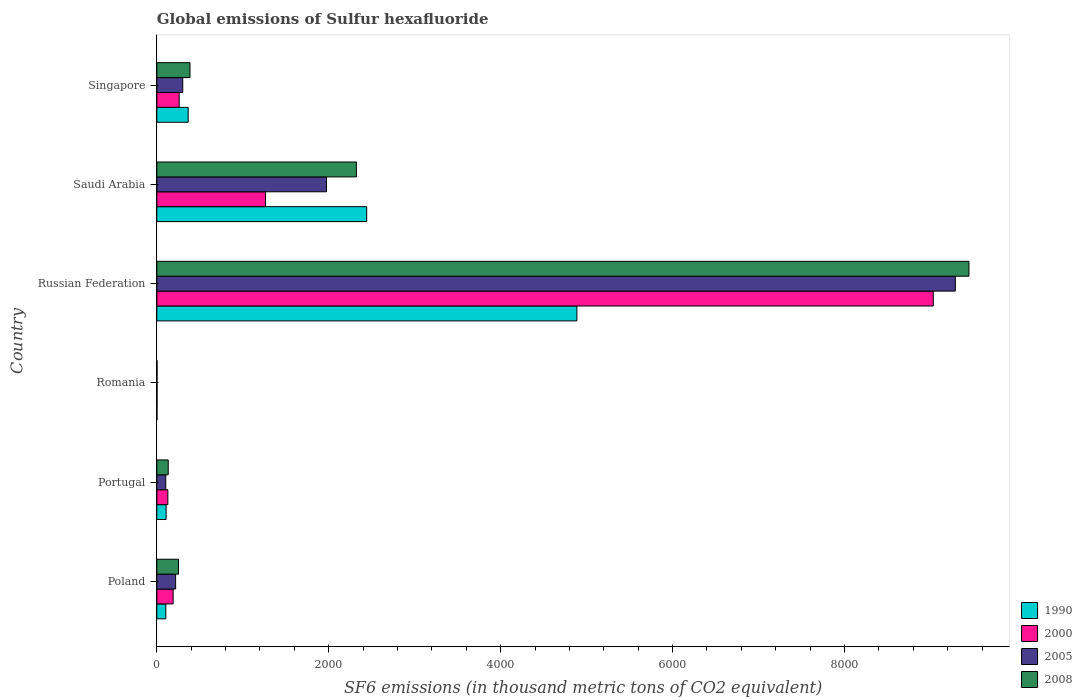How many different coloured bars are there?
Provide a succinct answer. 4. How many groups of bars are there?
Offer a terse response. 6. Are the number of bars per tick equal to the number of legend labels?
Your answer should be very brief. Yes. How many bars are there on the 6th tick from the bottom?
Provide a short and direct response. 4. What is the label of the 5th group of bars from the top?
Provide a short and direct response. Portugal. Across all countries, what is the maximum global emissions of Sulfur hexafluoride in 1990?
Your response must be concise. 4886.8. Across all countries, what is the minimum global emissions of Sulfur hexafluoride in 2005?
Make the answer very short. 2.2. In which country was the global emissions of Sulfur hexafluoride in 2008 maximum?
Make the answer very short. Russian Federation. In which country was the global emissions of Sulfur hexafluoride in 2005 minimum?
Provide a succinct answer. Romania. What is the total global emissions of Sulfur hexafluoride in 1990 in the graph?
Your answer should be very brief. 7906.7. What is the difference between the global emissions of Sulfur hexafluoride in 2000 in Poland and that in Russian Federation?
Keep it short and to the point. -8843.4. What is the difference between the global emissions of Sulfur hexafluoride in 1990 in Russian Federation and the global emissions of Sulfur hexafluoride in 2005 in Romania?
Provide a succinct answer. 4884.6. What is the average global emissions of Sulfur hexafluoride in 2005 per country?
Ensure brevity in your answer.  1981.57. What is the difference between the global emissions of Sulfur hexafluoride in 2008 and global emissions of Sulfur hexafluoride in 2000 in Poland?
Your response must be concise. 61.9. In how many countries, is the global emissions of Sulfur hexafluoride in 2005 greater than 1200 thousand metric tons?
Keep it short and to the point. 2. What is the ratio of the global emissions of Sulfur hexafluoride in 2008 in Saudi Arabia to that in Singapore?
Provide a short and direct response. 6.02. Is the global emissions of Sulfur hexafluoride in 2000 in Romania less than that in Saudi Arabia?
Ensure brevity in your answer.  Yes. Is the difference between the global emissions of Sulfur hexafluoride in 2008 in Russian Federation and Singapore greater than the difference between the global emissions of Sulfur hexafluoride in 2000 in Russian Federation and Singapore?
Ensure brevity in your answer.  Yes. What is the difference between the highest and the second highest global emissions of Sulfur hexafluoride in 2000?
Make the answer very short. 7768.6. What is the difference between the highest and the lowest global emissions of Sulfur hexafluoride in 2000?
Provide a succinct answer. 9031.2. Is the sum of the global emissions of Sulfur hexafluoride in 1990 in Russian Federation and Saudi Arabia greater than the maximum global emissions of Sulfur hexafluoride in 2008 across all countries?
Your answer should be very brief. No. Is it the case that in every country, the sum of the global emissions of Sulfur hexafluoride in 2008 and global emissions of Sulfur hexafluoride in 2005 is greater than the sum of global emissions of Sulfur hexafluoride in 1990 and global emissions of Sulfur hexafluoride in 2000?
Provide a succinct answer. No. Is it the case that in every country, the sum of the global emissions of Sulfur hexafluoride in 2005 and global emissions of Sulfur hexafluoride in 2000 is greater than the global emissions of Sulfur hexafluoride in 1990?
Your answer should be very brief. Yes. How many bars are there?
Ensure brevity in your answer.  24. How many countries are there in the graph?
Offer a very short reply. 6. Are the values on the major ticks of X-axis written in scientific E-notation?
Provide a short and direct response. No. Where does the legend appear in the graph?
Provide a succinct answer. Bottom right. How many legend labels are there?
Ensure brevity in your answer.  4. How are the legend labels stacked?
Provide a short and direct response. Vertical. What is the title of the graph?
Give a very brief answer. Global emissions of Sulfur hexafluoride. What is the label or title of the X-axis?
Keep it short and to the point. SF6 emissions (in thousand metric tons of CO2 equivalent). What is the SF6 emissions (in thousand metric tons of CO2 equivalent) of 1990 in Poland?
Make the answer very short. 104.3. What is the SF6 emissions (in thousand metric tons of CO2 equivalent) of 2000 in Poland?
Ensure brevity in your answer.  189.8. What is the SF6 emissions (in thousand metric tons of CO2 equivalent) of 2005 in Poland?
Give a very brief answer. 218.5. What is the SF6 emissions (in thousand metric tons of CO2 equivalent) in 2008 in Poland?
Offer a terse response. 251.7. What is the SF6 emissions (in thousand metric tons of CO2 equivalent) of 1990 in Portugal?
Ensure brevity in your answer.  108. What is the SF6 emissions (in thousand metric tons of CO2 equivalent) of 2000 in Portugal?
Ensure brevity in your answer.  128. What is the SF6 emissions (in thousand metric tons of CO2 equivalent) of 2005 in Portugal?
Offer a very short reply. 103.8. What is the SF6 emissions (in thousand metric tons of CO2 equivalent) in 2008 in Portugal?
Your answer should be very brief. 132.4. What is the SF6 emissions (in thousand metric tons of CO2 equivalent) of 2000 in Romania?
Your answer should be compact. 2. What is the SF6 emissions (in thousand metric tons of CO2 equivalent) in 1990 in Russian Federation?
Keep it short and to the point. 4886.8. What is the SF6 emissions (in thousand metric tons of CO2 equivalent) in 2000 in Russian Federation?
Provide a short and direct response. 9033.2. What is the SF6 emissions (in thousand metric tons of CO2 equivalent) of 2005 in Russian Federation?
Offer a very short reply. 9289.9. What is the SF6 emissions (in thousand metric tons of CO2 equivalent) in 2008 in Russian Federation?
Your response must be concise. 9448.2. What is the SF6 emissions (in thousand metric tons of CO2 equivalent) of 1990 in Saudi Arabia?
Give a very brief answer. 2441.3. What is the SF6 emissions (in thousand metric tons of CO2 equivalent) of 2000 in Saudi Arabia?
Ensure brevity in your answer.  1264.6. What is the SF6 emissions (in thousand metric tons of CO2 equivalent) in 2005 in Saudi Arabia?
Provide a short and direct response. 1973.8. What is the SF6 emissions (in thousand metric tons of CO2 equivalent) in 2008 in Saudi Arabia?
Give a very brief answer. 2321.8. What is the SF6 emissions (in thousand metric tons of CO2 equivalent) of 1990 in Singapore?
Offer a terse response. 364.7. What is the SF6 emissions (in thousand metric tons of CO2 equivalent) in 2000 in Singapore?
Your answer should be compact. 259.8. What is the SF6 emissions (in thousand metric tons of CO2 equivalent) of 2005 in Singapore?
Offer a very short reply. 301.2. What is the SF6 emissions (in thousand metric tons of CO2 equivalent) in 2008 in Singapore?
Offer a very short reply. 385.5. Across all countries, what is the maximum SF6 emissions (in thousand metric tons of CO2 equivalent) in 1990?
Provide a short and direct response. 4886.8. Across all countries, what is the maximum SF6 emissions (in thousand metric tons of CO2 equivalent) in 2000?
Provide a succinct answer. 9033.2. Across all countries, what is the maximum SF6 emissions (in thousand metric tons of CO2 equivalent) of 2005?
Your answer should be compact. 9289.9. Across all countries, what is the maximum SF6 emissions (in thousand metric tons of CO2 equivalent) in 2008?
Provide a succinct answer. 9448.2. Across all countries, what is the minimum SF6 emissions (in thousand metric tons of CO2 equivalent) in 1990?
Your answer should be very brief. 1.6. Across all countries, what is the minimum SF6 emissions (in thousand metric tons of CO2 equivalent) in 2000?
Offer a terse response. 2. Across all countries, what is the minimum SF6 emissions (in thousand metric tons of CO2 equivalent) in 2005?
Your response must be concise. 2.2. What is the total SF6 emissions (in thousand metric tons of CO2 equivalent) of 1990 in the graph?
Provide a short and direct response. 7906.7. What is the total SF6 emissions (in thousand metric tons of CO2 equivalent) of 2000 in the graph?
Give a very brief answer. 1.09e+04. What is the total SF6 emissions (in thousand metric tons of CO2 equivalent) of 2005 in the graph?
Keep it short and to the point. 1.19e+04. What is the total SF6 emissions (in thousand metric tons of CO2 equivalent) of 2008 in the graph?
Your answer should be compact. 1.25e+04. What is the difference between the SF6 emissions (in thousand metric tons of CO2 equivalent) in 1990 in Poland and that in Portugal?
Provide a short and direct response. -3.7. What is the difference between the SF6 emissions (in thousand metric tons of CO2 equivalent) of 2000 in Poland and that in Portugal?
Keep it short and to the point. 61.8. What is the difference between the SF6 emissions (in thousand metric tons of CO2 equivalent) of 2005 in Poland and that in Portugal?
Give a very brief answer. 114.7. What is the difference between the SF6 emissions (in thousand metric tons of CO2 equivalent) in 2008 in Poland and that in Portugal?
Offer a terse response. 119.3. What is the difference between the SF6 emissions (in thousand metric tons of CO2 equivalent) in 1990 in Poland and that in Romania?
Give a very brief answer. 102.7. What is the difference between the SF6 emissions (in thousand metric tons of CO2 equivalent) in 2000 in Poland and that in Romania?
Offer a very short reply. 187.8. What is the difference between the SF6 emissions (in thousand metric tons of CO2 equivalent) of 2005 in Poland and that in Romania?
Keep it short and to the point. 216.3. What is the difference between the SF6 emissions (in thousand metric tons of CO2 equivalent) of 2008 in Poland and that in Romania?
Provide a succinct answer. 249.4. What is the difference between the SF6 emissions (in thousand metric tons of CO2 equivalent) of 1990 in Poland and that in Russian Federation?
Provide a short and direct response. -4782.5. What is the difference between the SF6 emissions (in thousand metric tons of CO2 equivalent) of 2000 in Poland and that in Russian Federation?
Offer a terse response. -8843.4. What is the difference between the SF6 emissions (in thousand metric tons of CO2 equivalent) of 2005 in Poland and that in Russian Federation?
Your response must be concise. -9071.4. What is the difference between the SF6 emissions (in thousand metric tons of CO2 equivalent) in 2008 in Poland and that in Russian Federation?
Your response must be concise. -9196.5. What is the difference between the SF6 emissions (in thousand metric tons of CO2 equivalent) of 1990 in Poland and that in Saudi Arabia?
Offer a very short reply. -2337. What is the difference between the SF6 emissions (in thousand metric tons of CO2 equivalent) in 2000 in Poland and that in Saudi Arabia?
Make the answer very short. -1074.8. What is the difference between the SF6 emissions (in thousand metric tons of CO2 equivalent) in 2005 in Poland and that in Saudi Arabia?
Your answer should be compact. -1755.3. What is the difference between the SF6 emissions (in thousand metric tons of CO2 equivalent) in 2008 in Poland and that in Saudi Arabia?
Your response must be concise. -2070.1. What is the difference between the SF6 emissions (in thousand metric tons of CO2 equivalent) in 1990 in Poland and that in Singapore?
Offer a terse response. -260.4. What is the difference between the SF6 emissions (in thousand metric tons of CO2 equivalent) in 2000 in Poland and that in Singapore?
Keep it short and to the point. -70. What is the difference between the SF6 emissions (in thousand metric tons of CO2 equivalent) of 2005 in Poland and that in Singapore?
Your answer should be compact. -82.7. What is the difference between the SF6 emissions (in thousand metric tons of CO2 equivalent) in 2008 in Poland and that in Singapore?
Ensure brevity in your answer.  -133.8. What is the difference between the SF6 emissions (in thousand metric tons of CO2 equivalent) in 1990 in Portugal and that in Romania?
Keep it short and to the point. 106.4. What is the difference between the SF6 emissions (in thousand metric tons of CO2 equivalent) in 2000 in Portugal and that in Romania?
Make the answer very short. 126. What is the difference between the SF6 emissions (in thousand metric tons of CO2 equivalent) in 2005 in Portugal and that in Romania?
Provide a short and direct response. 101.6. What is the difference between the SF6 emissions (in thousand metric tons of CO2 equivalent) of 2008 in Portugal and that in Romania?
Your answer should be very brief. 130.1. What is the difference between the SF6 emissions (in thousand metric tons of CO2 equivalent) in 1990 in Portugal and that in Russian Federation?
Keep it short and to the point. -4778.8. What is the difference between the SF6 emissions (in thousand metric tons of CO2 equivalent) of 2000 in Portugal and that in Russian Federation?
Offer a very short reply. -8905.2. What is the difference between the SF6 emissions (in thousand metric tons of CO2 equivalent) in 2005 in Portugal and that in Russian Federation?
Make the answer very short. -9186.1. What is the difference between the SF6 emissions (in thousand metric tons of CO2 equivalent) in 2008 in Portugal and that in Russian Federation?
Provide a short and direct response. -9315.8. What is the difference between the SF6 emissions (in thousand metric tons of CO2 equivalent) of 1990 in Portugal and that in Saudi Arabia?
Your answer should be very brief. -2333.3. What is the difference between the SF6 emissions (in thousand metric tons of CO2 equivalent) in 2000 in Portugal and that in Saudi Arabia?
Provide a succinct answer. -1136.6. What is the difference between the SF6 emissions (in thousand metric tons of CO2 equivalent) in 2005 in Portugal and that in Saudi Arabia?
Give a very brief answer. -1870. What is the difference between the SF6 emissions (in thousand metric tons of CO2 equivalent) in 2008 in Portugal and that in Saudi Arabia?
Your response must be concise. -2189.4. What is the difference between the SF6 emissions (in thousand metric tons of CO2 equivalent) of 1990 in Portugal and that in Singapore?
Offer a terse response. -256.7. What is the difference between the SF6 emissions (in thousand metric tons of CO2 equivalent) of 2000 in Portugal and that in Singapore?
Your answer should be very brief. -131.8. What is the difference between the SF6 emissions (in thousand metric tons of CO2 equivalent) of 2005 in Portugal and that in Singapore?
Ensure brevity in your answer.  -197.4. What is the difference between the SF6 emissions (in thousand metric tons of CO2 equivalent) of 2008 in Portugal and that in Singapore?
Your answer should be very brief. -253.1. What is the difference between the SF6 emissions (in thousand metric tons of CO2 equivalent) of 1990 in Romania and that in Russian Federation?
Offer a terse response. -4885.2. What is the difference between the SF6 emissions (in thousand metric tons of CO2 equivalent) of 2000 in Romania and that in Russian Federation?
Your answer should be compact. -9031.2. What is the difference between the SF6 emissions (in thousand metric tons of CO2 equivalent) of 2005 in Romania and that in Russian Federation?
Make the answer very short. -9287.7. What is the difference between the SF6 emissions (in thousand metric tons of CO2 equivalent) in 2008 in Romania and that in Russian Federation?
Make the answer very short. -9445.9. What is the difference between the SF6 emissions (in thousand metric tons of CO2 equivalent) of 1990 in Romania and that in Saudi Arabia?
Keep it short and to the point. -2439.7. What is the difference between the SF6 emissions (in thousand metric tons of CO2 equivalent) of 2000 in Romania and that in Saudi Arabia?
Offer a very short reply. -1262.6. What is the difference between the SF6 emissions (in thousand metric tons of CO2 equivalent) in 2005 in Romania and that in Saudi Arabia?
Offer a very short reply. -1971.6. What is the difference between the SF6 emissions (in thousand metric tons of CO2 equivalent) in 2008 in Romania and that in Saudi Arabia?
Keep it short and to the point. -2319.5. What is the difference between the SF6 emissions (in thousand metric tons of CO2 equivalent) in 1990 in Romania and that in Singapore?
Your response must be concise. -363.1. What is the difference between the SF6 emissions (in thousand metric tons of CO2 equivalent) of 2000 in Romania and that in Singapore?
Your answer should be compact. -257.8. What is the difference between the SF6 emissions (in thousand metric tons of CO2 equivalent) in 2005 in Romania and that in Singapore?
Make the answer very short. -299. What is the difference between the SF6 emissions (in thousand metric tons of CO2 equivalent) in 2008 in Romania and that in Singapore?
Your answer should be compact. -383.2. What is the difference between the SF6 emissions (in thousand metric tons of CO2 equivalent) of 1990 in Russian Federation and that in Saudi Arabia?
Provide a succinct answer. 2445.5. What is the difference between the SF6 emissions (in thousand metric tons of CO2 equivalent) of 2000 in Russian Federation and that in Saudi Arabia?
Your answer should be very brief. 7768.6. What is the difference between the SF6 emissions (in thousand metric tons of CO2 equivalent) of 2005 in Russian Federation and that in Saudi Arabia?
Offer a very short reply. 7316.1. What is the difference between the SF6 emissions (in thousand metric tons of CO2 equivalent) in 2008 in Russian Federation and that in Saudi Arabia?
Provide a succinct answer. 7126.4. What is the difference between the SF6 emissions (in thousand metric tons of CO2 equivalent) of 1990 in Russian Federation and that in Singapore?
Keep it short and to the point. 4522.1. What is the difference between the SF6 emissions (in thousand metric tons of CO2 equivalent) in 2000 in Russian Federation and that in Singapore?
Offer a terse response. 8773.4. What is the difference between the SF6 emissions (in thousand metric tons of CO2 equivalent) in 2005 in Russian Federation and that in Singapore?
Ensure brevity in your answer.  8988.7. What is the difference between the SF6 emissions (in thousand metric tons of CO2 equivalent) of 2008 in Russian Federation and that in Singapore?
Give a very brief answer. 9062.7. What is the difference between the SF6 emissions (in thousand metric tons of CO2 equivalent) of 1990 in Saudi Arabia and that in Singapore?
Offer a terse response. 2076.6. What is the difference between the SF6 emissions (in thousand metric tons of CO2 equivalent) of 2000 in Saudi Arabia and that in Singapore?
Provide a short and direct response. 1004.8. What is the difference between the SF6 emissions (in thousand metric tons of CO2 equivalent) in 2005 in Saudi Arabia and that in Singapore?
Provide a succinct answer. 1672.6. What is the difference between the SF6 emissions (in thousand metric tons of CO2 equivalent) of 2008 in Saudi Arabia and that in Singapore?
Your response must be concise. 1936.3. What is the difference between the SF6 emissions (in thousand metric tons of CO2 equivalent) of 1990 in Poland and the SF6 emissions (in thousand metric tons of CO2 equivalent) of 2000 in Portugal?
Your answer should be very brief. -23.7. What is the difference between the SF6 emissions (in thousand metric tons of CO2 equivalent) in 1990 in Poland and the SF6 emissions (in thousand metric tons of CO2 equivalent) in 2008 in Portugal?
Give a very brief answer. -28.1. What is the difference between the SF6 emissions (in thousand metric tons of CO2 equivalent) of 2000 in Poland and the SF6 emissions (in thousand metric tons of CO2 equivalent) of 2008 in Portugal?
Ensure brevity in your answer.  57.4. What is the difference between the SF6 emissions (in thousand metric tons of CO2 equivalent) of 2005 in Poland and the SF6 emissions (in thousand metric tons of CO2 equivalent) of 2008 in Portugal?
Make the answer very short. 86.1. What is the difference between the SF6 emissions (in thousand metric tons of CO2 equivalent) of 1990 in Poland and the SF6 emissions (in thousand metric tons of CO2 equivalent) of 2000 in Romania?
Keep it short and to the point. 102.3. What is the difference between the SF6 emissions (in thousand metric tons of CO2 equivalent) in 1990 in Poland and the SF6 emissions (in thousand metric tons of CO2 equivalent) in 2005 in Romania?
Offer a terse response. 102.1. What is the difference between the SF6 emissions (in thousand metric tons of CO2 equivalent) of 1990 in Poland and the SF6 emissions (in thousand metric tons of CO2 equivalent) of 2008 in Romania?
Your response must be concise. 102. What is the difference between the SF6 emissions (in thousand metric tons of CO2 equivalent) of 2000 in Poland and the SF6 emissions (in thousand metric tons of CO2 equivalent) of 2005 in Romania?
Provide a succinct answer. 187.6. What is the difference between the SF6 emissions (in thousand metric tons of CO2 equivalent) of 2000 in Poland and the SF6 emissions (in thousand metric tons of CO2 equivalent) of 2008 in Romania?
Give a very brief answer. 187.5. What is the difference between the SF6 emissions (in thousand metric tons of CO2 equivalent) in 2005 in Poland and the SF6 emissions (in thousand metric tons of CO2 equivalent) in 2008 in Romania?
Give a very brief answer. 216.2. What is the difference between the SF6 emissions (in thousand metric tons of CO2 equivalent) in 1990 in Poland and the SF6 emissions (in thousand metric tons of CO2 equivalent) in 2000 in Russian Federation?
Provide a short and direct response. -8928.9. What is the difference between the SF6 emissions (in thousand metric tons of CO2 equivalent) in 1990 in Poland and the SF6 emissions (in thousand metric tons of CO2 equivalent) in 2005 in Russian Federation?
Offer a terse response. -9185.6. What is the difference between the SF6 emissions (in thousand metric tons of CO2 equivalent) in 1990 in Poland and the SF6 emissions (in thousand metric tons of CO2 equivalent) in 2008 in Russian Federation?
Your answer should be compact. -9343.9. What is the difference between the SF6 emissions (in thousand metric tons of CO2 equivalent) in 2000 in Poland and the SF6 emissions (in thousand metric tons of CO2 equivalent) in 2005 in Russian Federation?
Make the answer very short. -9100.1. What is the difference between the SF6 emissions (in thousand metric tons of CO2 equivalent) in 2000 in Poland and the SF6 emissions (in thousand metric tons of CO2 equivalent) in 2008 in Russian Federation?
Offer a terse response. -9258.4. What is the difference between the SF6 emissions (in thousand metric tons of CO2 equivalent) of 2005 in Poland and the SF6 emissions (in thousand metric tons of CO2 equivalent) of 2008 in Russian Federation?
Provide a short and direct response. -9229.7. What is the difference between the SF6 emissions (in thousand metric tons of CO2 equivalent) in 1990 in Poland and the SF6 emissions (in thousand metric tons of CO2 equivalent) in 2000 in Saudi Arabia?
Your answer should be very brief. -1160.3. What is the difference between the SF6 emissions (in thousand metric tons of CO2 equivalent) of 1990 in Poland and the SF6 emissions (in thousand metric tons of CO2 equivalent) of 2005 in Saudi Arabia?
Your response must be concise. -1869.5. What is the difference between the SF6 emissions (in thousand metric tons of CO2 equivalent) in 1990 in Poland and the SF6 emissions (in thousand metric tons of CO2 equivalent) in 2008 in Saudi Arabia?
Keep it short and to the point. -2217.5. What is the difference between the SF6 emissions (in thousand metric tons of CO2 equivalent) in 2000 in Poland and the SF6 emissions (in thousand metric tons of CO2 equivalent) in 2005 in Saudi Arabia?
Give a very brief answer. -1784. What is the difference between the SF6 emissions (in thousand metric tons of CO2 equivalent) in 2000 in Poland and the SF6 emissions (in thousand metric tons of CO2 equivalent) in 2008 in Saudi Arabia?
Provide a short and direct response. -2132. What is the difference between the SF6 emissions (in thousand metric tons of CO2 equivalent) of 2005 in Poland and the SF6 emissions (in thousand metric tons of CO2 equivalent) of 2008 in Saudi Arabia?
Keep it short and to the point. -2103.3. What is the difference between the SF6 emissions (in thousand metric tons of CO2 equivalent) of 1990 in Poland and the SF6 emissions (in thousand metric tons of CO2 equivalent) of 2000 in Singapore?
Provide a short and direct response. -155.5. What is the difference between the SF6 emissions (in thousand metric tons of CO2 equivalent) of 1990 in Poland and the SF6 emissions (in thousand metric tons of CO2 equivalent) of 2005 in Singapore?
Ensure brevity in your answer.  -196.9. What is the difference between the SF6 emissions (in thousand metric tons of CO2 equivalent) in 1990 in Poland and the SF6 emissions (in thousand metric tons of CO2 equivalent) in 2008 in Singapore?
Your answer should be very brief. -281.2. What is the difference between the SF6 emissions (in thousand metric tons of CO2 equivalent) of 2000 in Poland and the SF6 emissions (in thousand metric tons of CO2 equivalent) of 2005 in Singapore?
Offer a terse response. -111.4. What is the difference between the SF6 emissions (in thousand metric tons of CO2 equivalent) of 2000 in Poland and the SF6 emissions (in thousand metric tons of CO2 equivalent) of 2008 in Singapore?
Your answer should be compact. -195.7. What is the difference between the SF6 emissions (in thousand metric tons of CO2 equivalent) in 2005 in Poland and the SF6 emissions (in thousand metric tons of CO2 equivalent) in 2008 in Singapore?
Your answer should be very brief. -167. What is the difference between the SF6 emissions (in thousand metric tons of CO2 equivalent) in 1990 in Portugal and the SF6 emissions (in thousand metric tons of CO2 equivalent) in 2000 in Romania?
Provide a short and direct response. 106. What is the difference between the SF6 emissions (in thousand metric tons of CO2 equivalent) in 1990 in Portugal and the SF6 emissions (in thousand metric tons of CO2 equivalent) in 2005 in Romania?
Make the answer very short. 105.8. What is the difference between the SF6 emissions (in thousand metric tons of CO2 equivalent) of 1990 in Portugal and the SF6 emissions (in thousand metric tons of CO2 equivalent) of 2008 in Romania?
Your answer should be very brief. 105.7. What is the difference between the SF6 emissions (in thousand metric tons of CO2 equivalent) of 2000 in Portugal and the SF6 emissions (in thousand metric tons of CO2 equivalent) of 2005 in Romania?
Ensure brevity in your answer.  125.8. What is the difference between the SF6 emissions (in thousand metric tons of CO2 equivalent) in 2000 in Portugal and the SF6 emissions (in thousand metric tons of CO2 equivalent) in 2008 in Romania?
Your response must be concise. 125.7. What is the difference between the SF6 emissions (in thousand metric tons of CO2 equivalent) in 2005 in Portugal and the SF6 emissions (in thousand metric tons of CO2 equivalent) in 2008 in Romania?
Keep it short and to the point. 101.5. What is the difference between the SF6 emissions (in thousand metric tons of CO2 equivalent) in 1990 in Portugal and the SF6 emissions (in thousand metric tons of CO2 equivalent) in 2000 in Russian Federation?
Your answer should be compact. -8925.2. What is the difference between the SF6 emissions (in thousand metric tons of CO2 equivalent) in 1990 in Portugal and the SF6 emissions (in thousand metric tons of CO2 equivalent) in 2005 in Russian Federation?
Offer a very short reply. -9181.9. What is the difference between the SF6 emissions (in thousand metric tons of CO2 equivalent) of 1990 in Portugal and the SF6 emissions (in thousand metric tons of CO2 equivalent) of 2008 in Russian Federation?
Provide a succinct answer. -9340.2. What is the difference between the SF6 emissions (in thousand metric tons of CO2 equivalent) of 2000 in Portugal and the SF6 emissions (in thousand metric tons of CO2 equivalent) of 2005 in Russian Federation?
Provide a succinct answer. -9161.9. What is the difference between the SF6 emissions (in thousand metric tons of CO2 equivalent) in 2000 in Portugal and the SF6 emissions (in thousand metric tons of CO2 equivalent) in 2008 in Russian Federation?
Provide a succinct answer. -9320.2. What is the difference between the SF6 emissions (in thousand metric tons of CO2 equivalent) in 2005 in Portugal and the SF6 emissions (in thousand metric tons of CO2 equivalent) in 2008 in Russian Federation?
Ensure brevity in your answer.  -9344.4. What is the difference between the SF6 emissions (in thousand metric tons of CO2 equivalent) of 1990 in Portugal and the SF6 emissions (in thousand metric tons of CO2 equivalent) of 2000 in Saudi Arabia?
Give a very brief answer. -1156.6. What is the difference between the SF6 emissions (in thousand metric tons of CO2 equivalent) in 1990 in Portugal and the SF6 emissions (in thousand metric tons of CO2 equivalent) in 2005 in Saudi Arabia?
Your answer should be compact. -1865.8. What is the difference between the SF6 emissions (in thousand metric tons of CO2 equivalent) in 1990 in Portugal and the SF6 emissions (in thousand metric tons of CO2 equivalent) in 2008 in Saudi Arabia?
Provide a short and direct response. -2213.8. What is the difference between the SF6 emissions (in thousand metric tons of CO2 equivalent) of 2000 in Portugal and the SF6 emissions (in thousand metric tons of CO2 equivalent) of 2005 in Saudi Arabia?
Your answer should be compact. -1845.8. What is the difference between the SF6 emissions (in thousand metric tons of CO2 equivalent) in 2000 in Portugal and the SF6 emissions (in thousand metric tons of CO2 equivalent) in 2008 in Saudi Arabia?
Provide a short and direct response. -2193.8. What is the difference between the SF6 emissions (in thousand metric tons of CO2 equivalent) in 2005 in Portugal and the SF6 emissions (in thousand metric tons of CO2 equivalent) in 2008 in Saudi Arabia?
Provide a succinct answer. -2218. What is the difference between the SF6 emissions (in thousand metric tons of CO2 equivalent) in 1990 in Portugal and the SF6 emissions (in thousand metric tons of CO2 equivalent) in 2000 in Singapore?
Provide a succinct answer. -151.8. What is the difference between the SF6 emissions (in thousand metric tons of CO2 equivalent) in 1990 in Portugal and the SF6 emissions (in thousand metric tons of CO2 equivalent) in 2005 in Singapore?
Make the answer very short. -193.2. What is the difference between the SF6 emissions (in thousand metric tons of CO2 equivalent) in 1990 in Portugal and the SF6 emissions (in thousand metric tons of CO2 equivalent) in 2008 in Singapore?
Ensure brevity in your answer.  -277.5. What is the difference between the SF6 emissions (in thousand metric tons of CO2 equivalent) in 2000 in Portugal and the SF6 emissions (in thousand metric tons of CO2 equivalent) in 2005 in Singapore?
Keep it short and to the point. -173.2. What is the difference between the SF6 emissions (in thousand metric tons of CO2 equivalent) of 2000 in Portugal and the SF6 emissions (in thousand metric tons of CO2 equivalent) of 2008 in Singapore?
Make the answer very short. -257.5. What is the difference between the SF6 emissions (in thousand metric tons of CO2 equivalent) of 2005 in Portugal and the SF6 emissions (in thousand metric tons of CO2 equivalent) of 2008 in Singapore?
Make the answer very short. -281.7. What is the difference between the SF6 emissions (in thousand metric tons of CO2 equivalent) of 1990 in Romania and the SF6 emissions (in thousand metric tons of CO2 equivalent) of 2000 in Russian Federation?
Offer a terse response. -9031.6. What is the difference between the SF6 emissions (in thousand metric tons of CO2 equivalent) in 1990 in Romania and the SF6 emissions (in thousand metric tons of CO2 equivalent) in 2005 in Russian Federation?
Your answer should be compact. -9288.3. What is the difference between the SF6 emissions (in thousand metric tons of CO2 equivalent) of 1990 in Romania and the SF6 emissions (in thousand metric tons of CO2 equivalent) of 2008 in Russian Federation?
Make the answer very short. -9446.6. What is the difference between the SF6 emissions (in thousand metric tons of CO2 equivalent) in 2000 in Romania and the SF6 emissions (in thousand metric tons of CO2 equivalent) in 2005 in Russian Federation?
Your answer should be compact. -9287.9. What is the difference between the SF6 emissions (in thousand metric tons of CO2 equivalent) of 2000 in Romania and the SF6 emissions (in thousand metric tons of CO2 equivalent) of 2008 in Russian Federation?
Offer a very short reply. -9446.2. What is the difference between the SF6 emissions (in thousand metric tons of CO2 equivalent) in 2005 in Romania and the SF6 emissions (in thousand metric tons of CO2 equivalent) in 2008 in Russian Federation?
Your answer should be very brief. -9446. What is the difference between the SF6 emissions (in thousand metric tons of CO2 equivalent) in 1990 in Romania and the SF6 emissions (in thousand metric tons of CO2 equivalent) in 2000 in Saudi Arabia?
Your answer should be compact. -1263. What is the difference between the SF6 emissions (in thousand metric tons of CO2 equivalent) of 1990 in Romania and the SF6 emissions (in thousand metric tons of CO2 equivalent) of 2005 in Saudi Arabia?
Provide a short and direct response. -1972.2. What is the difference between the SF6 emissions (in thousand metric tons of CO2 equivalent) of 1990 in Romania and the SF6 emissions (in thousand metric tons of CO2 equivalent) of 2008 in Saudi Arabia?
Offer a terse response. -2320.2. What is the difference between the SF6 emissions (in thousand metric tons of CO2 equivalent) of 2000 in Romania and the SF6 emissions (in thousand metric tons of CO2 equivalent) of 2005 in Saudi Arabia?
Give a very brief answer. -1971.8. What is the difference between the SF6 emissions (in thousand metric tons of CO2 equivalent) in 2000 in Romania and the SF6 emissions (in thousand metric tons of CO2 equivalent) in 2008 in Saudi Arabia?
Your answer should be compact. -2319.8. What is the difference between the SF6 emissions (in thousand metric tons of CO2 equivalent) in 2005 in Romania and the SF6 emissions (in thousand metric tons of CO2 equivalent) in 2008 in Saudi Arabia?
Keep it short and to the point. -2319.6. What is the difference between the SF6 emissions (in thousand metric tons of CO2 equivalent) in 1990 in Romania and the SF6 emissions (in thousand metric tons of CO2 equivalent) in 2000 in Singapore?
Provide a succinct answer. -258.2. What is the difference between the SF6 emissions (in thousand metric tons of CO2 equivalent) of 1990 in Romania and the SF6 emissions (in thousand metric tons of CO2 equivalent) of 2005 in Singapore?
Offer a terse response. -299.6. What is the difference between the SF6 emissions (in thousand metric tons of CO2 equivalent) of 1990 in Romania and the SF6 emissions (in thousand metric tons of CO2 equivalent) of 2008 in Singapore?
Offer a very short reply. -383.9. What is the difference between the SF6 emissions (in thousand metric tons of CO2 equivalent) in 2000 in Romania and the SF6 emissions (in thousand metric tons of CO2 equivalent) in 2005 in Singapore?
Ensure brevity in your answer.  -299.2. What is the difference between the SF6 emissions (in thousand metric tons of CO2 equivalent) in 2000 in Romania and the SF6 emissions (in thousand metric tons of CO2 equivalent) in 2008 in Singapore?
Make the answer very short. -383.5. What is the difference between the SF6 emissions (in thousand metric tons of CO2 equivalent) in 2005 in Romania and the SF6 emissions (in thousand metric tons of CO2 equivalent) in 2008 in Singapore?
Offer a very short reply. -383.3. What is the difference between the SF6 emissions (in thousand metric tons of CO2 equivalent) in 1990 in Russian Federation and the SF6 emissions (in thousand metric tons of CO2 equivalent) in 2000 in Saudi Arabia?
Offer a very short reply. 3622.2. What is the difference between the SF6 emissions (in thousand metric tons of CO2 equivalent) in 1990 in Russian Federation and the SF6 emissions (in thousand metric tons of CO2 equivalent) in 2005 in Saudi Arabia?
Provide a succinct answer. 2913. What is the difference between the SF6 emissions (in thousand metric tons of CO2 equivalent) in 1990 in Russian Federation and the SF6 emissions (in thousand metric tons of CO2 equivalent) in 2008 in Saudi Arabia?
Keep it short and to the point. 2565. What is the difference between the SF6 emissions (in thousand metric tons of CO2 equivalent) of 2000 in Russian Federation and the SF6 emissions (in thousand metric tons of CO2 equivalent) of 2005 in Saudi Arabia?
Offer a very short reply. 7059.4. What is the difference between the SF6 emissions (in thousand metric tons of CO2 equivalent) of 2000 in Russian Federation and the SF6 emissions (in thousand metric tons of CO2 equivalent) of 2008 in Saudi Arabia?
Provide a succinct answer. 6711.4. What is the difference between the SF6 emissions (in thousand metric tons of CO2 equivalent) in 2005 in Russian Federation and the SF6 emissions (in thousand metric tons of CO2 equivalent) in 2008 in Saudi Arabia?
Your response must be concise. 6968.1. What is the difference between the SF6 emissions (in thousand metric tons of CO2 equivalent) of 1990 in Russian Federation and the SF6 emissions (in thousand metric tons of CO2 equivalent) of 2000 in Singapore?
Give a very brief answer. 4627. What is the difference between the SF6 emissions (in thousand metric tons of CO2 equivalent) of 1990 in Russian Federation and the SF6 emissions (in thousand metric tons of CO2 equivalent) of 2005 in Singapore?
Provide a succinct answer. 4585.6. What is the difference between the SF6 emissions (in thousand metric tons of CO2 equivalent) of 1990 in Russian Federation and the SF6 emissions (in thousand metric tons of CO2 equivalent) of 2008 in Singapore?
Offer a terse response. 4501.3. What is the difference between the SF6 emissions (in thousand metric tons of CO2 equivalent) of 2000 in Russian Federation and the SF6 emissions (in thousand metric tons of CO2 equivalent) of 2005 in Singapore?
Your answer should be compact. 8732. What is the difference between the SF6 emissions (in thousand metric tons of CO2 equivalent) of 2000 in Russian Federation and the SF6 emissions (in thousand metric tons of CO2 equivalent) of 2008 in Singapore?
Provide a short and direct response. 8647.7. What is the difference between the SF6 emissions (in thousand metric tons of CO2 equivalent) in 2005 in Russian Federation and the SF6 emissions (in thousand metric tons of CO2 equivalent) in 2008 in Singapore?
Offer a very short reply. 8904.4. What is the difference between the SF6 emissions (in thousand metric tons of CO2 equivalent) in 1990 in Saudi Arabia and the SF6 emissions (in thousand metric tons of CO2 equivalent) in 2000 in Singapore?
Provide a succinct answer. 2181.5. What is the difference between the SF6 emissions (in thousand metric tons of CO2 equivalent) in 1990 in Saudi Arabia and the SF6 emissions (in thousand metric tons of CO2 equivalent) in 2005 in Singapore?
Offer a terse response. 2140.1. What is the difference between the SF6 emissions (in thousand metric tons of CO2 equivalent) of 1990 in Saudi Arabia and the SF6 emissions (in thousand metric tons of CO2 equivalent) of 2008 in Singapore?
Your answer should be very brief. 2055.8. What is the difference between the SF6 emissions (in thousand metric tons of CO2 equivalent) of 2000 in Saudi Arabia and the SF6 emissions (in thousand metric tons of CO2 equivalent) of 2005 in Singapore?
Give a very brief answer. 963.4. What is the difference between the SF6 emissions (in thousand metric tons of CO2 equivalent) in 2000 in Saudi Arabia and the SF6 emissions (in thousand metric tons of CO2 equivalent) in 2008 in Singapore?
Your response must be concise. 879.1. What is the difference between the SF6 emissions (in thousand metric tons of CO2 equivalent) of 2005 in Saudi Arabia and the SF6 emissions (in thousand metric tons of CO2 equivalent) of 2008 in Singapore?
Ensure brevity in your answer.  1588.3. What is the average SF6 emissions (in thousand metric tons of CO2 equivalent) of 1990 per country?
Your answer should be very brief. 1317.78. What is the average SF6 emissions (in thousand metric tons of CO2 equivalent) in 2000 per country?
Provide a succinct answer. 1812.9. What is the average SF6 emissions (in thousand metric tons of CO2 equivalent) of 2005 per country?
Your answer should be very brief. 1981.57. What is the average SF6 emissions (in thousand metric tons of CO2 equivalent) of 2008 per country?
Provide a short and direct response. 2090.32. What is the difference between the SF6 emissions (in thousand metric tons of CO2 equivalent) of 1990 and SF6 emissions (in thousand metric tons of CO2 equivalent) of 2000 in Poland?
Offer a terse response. -85.5. What is the difference between the SF6 emissions (in thousand metric tons of CO2 equivalent) of 1990 and SF6 emissions (in thousand metric tons of CO2 equivalent) of 2005 in Poland?
Keep it short and to the point. -114.2. What is the difference between the SF6 emissions (in thousand metric tons of CO2 equivalent) in 1990 and SF6 emissions (in thousand metric tons of CO2 equivalent) in 2008 in Poland?
Offer a very short reply. -147.4. What is the difference between the SF6 emissions (in thousand metric tons of CO2 equivalent) in 2000 and SF6 emissions (in thousand metric tons of CO2 equivalent) in 2005 in Poland?
Your answer should be very brief. -28.7. What is the difference between the SF6 emissions (in thousand metric tons of CO2 equivalent) in 2000 and SF6 emissions (in thousand metric tons of CO2 equivalent) in 2008 in Poland?
Your answer should be very brief. -61.9. What is the difference between the SF6 emissions (in thousand metric tons of CO2 equivalent) in 2005 and SF6 emissions (in thousand metric tons of CO2 equivalent) in 2008 in Poland?
Provide a succinct answer. -33.2. What is the difference between the SF6 emissions (in thousand metric tons of CO2 equivalent) of 1990 and SF6 emissions (in thousand metric tons of CO2 equivalent) of 2008 in Portugal?
Provide a succinct answer. -24.4. What is the difference between the SF6 emissions (in thousand metric tons of CO2 equivalent) in 2000 and SF6 emissions (in thousand metric tons of CO2 equivalent) in 2005 in Portugal?
Keep it short and to the point. 24.2. What is the difference between the SF6 emissions (in thousand metric tons of CO2 equivalent) of 2005 and SF6 emissions (in thousand metric tons of CO2 equivalent) of 2008 in Portugal?
Ensure brevity in your answer.  -28.6. What is the difference between the SF6 emissions (in thousand metric tons of CO2 equivalent) in 1990 and SF6 emissions (in thousand metric tons of CO2 equivalent) in 2000 in Romania?
Offer a very short reply. -0.4. What is the difference between the SF6 emissions (in thousand metric tons of CO2 equivalent) of 1990 and SF6 emissions (in thousand metric tons of CO2 equivalent) of 2008 in Romania?
Your answer should be compact. -0.7. What is the difference between the SF6 emissions (in thousand metric tons of CO2 equivalent) in 2000 and SF6 emissions (in thousand metric tons of CO2 equivalent) in 2005 in Romania?
Keep it short and to the point. -0.2. What is the difference between the SF6 emissions (in thousand metric tons of CO2 equivalent) of 2000 and SF6 emissions (in thousand metric tons of CO2 equivalent) of 2008 in Romania?
Provide a succinct answer. -0.3. What is the difference between the SF6 emissions (in thousand metric tons of CO2 equivalent) of 2005 and SF6 emissions (in thousand metric tons of CO2 equivalent) of 2008 in Romania?
Ensure brevity in your answer.  -0.1. What is the difference between the SF6 emissions (in thousand metric tons of CO2 equivalent) in 1990 and SF6 emissions (in thousand metric tons of CO2 equivalent) in 2000 in Russian Federation?
Make the answer very short. -4146.4. What is the difference between the SF6 emissions (in thousand metric tons of CO2 equivalent) of 1990 and SF6 emissions (in thousand metric tons of CO2 equivalent) of 2005 in Russian Federation?
Your answer should be compact. -4403.1. What is the difference between the SF6 emissions (in thousand metric tons of CO2 equivalent) of 1990 and SF6 emissions (in thousand metric tons of CO2 equivalent) of 2008 in Russian Federation?
Give a very brief answer. -4561.4. What is the difference between the SF6 emissions (in thousand metric tons of CO2 equivalent) in 2000 and SF6 emissions (in thousand metric tons of CO2 equivalent) in 2005 in Russian Federation?
Keep it short and to the point. -256.7. What is the difference between the SF6 emissions (in thousand metric tons of CO2 equivalent) in 2000 and SF6 emissions (in thousand metric tons of CO2 equivalent) in 2008 in Russian Federation?
Give a very brief answer. -415. What is the difference between the SF6 emissions (in thousand metric tons of CO2 equivalent) of 2005 and SF6 emissions (in thousand metric tons of CO2 equivalent) of 2008 in Russian Federation?
Your answer should be very brief. -158.3. What is the difference between the SF6 emissions (in thousand metric tons of CO2 equivalent) in 1990 and SF6 emissions (in thousand metric tons of CO2 equivalent) in 2000 in Saudi Arabia?
Ensure brevity in your answer.  1176.7. What is the difference between the SF6 emissions (in thousand metric tons of CO2 equivalent) of 1990 and SF6 emissions (in thousand metric tons of CO2 equivalent) of 2005 in Saudi Arabia?
Provide a short and direct response. 467.5. What is the difference between the SF6 emissions (in thousand metric tons of CO2 equivalent) of 1990 and SF6 emissions (in thousand metric tons of CO2 equivalent) of 2008 in Saudi Arabia?
Offer a terse response. 119.5. What is the difference between the SF6 emissions (in thousand metric tons of CO2 equivalent) of 2000 and SF6 emissions (in thousand metric tons of CO2 equivalent) of 2005 in Saudi Arabia?
Keep it short and to the point. -709.2. What is the difference between the SF6 emissions (in thousand metric tons of CO2 equivalent) of 2000 and SF6 emissions (in thousand metric tons of CO2 equivalent) of 2008 in Saudi Arabia?
Ensure brevity in your answer.  -1057.2. What is the difference between the SF6 emissions (in thousand metric tons of CO2 equivalent) in 2005 and SF6 emissions (in thousand metric tons of CO2 equivalent) in 2008 in Saudi Arabia?
Provide a short and direct response. -348. What is the difference between the SF6 emissions (in thousand metric tons of CO2 equivalent) in 1990 and SF6 emissions (in thousand metric tons of CO2 equivalent) in 2000 in Singapore?
Offer a terse response. 104.9. What is the difference between the SF6 emissions (in thousand metric tons of CO2 equivalent) in 1990 and SF6 emissions (in thousand metric tons of CO2 equivalent) in 2005 in Singapore?
Provide a short and direct response. 63.5. What is the difference between the SF6 emissions (in thousand metric tons of CO2 equivalent) of 1990 and SF6 emissions (in thousand metric tons of CO2 equivalent) of 2008 in Singapore?
Make the answer very short. -20.8. What is the difference between the SF6 emissions (in thousand metric tons of CO2 equivalent) in 2000 and SF6 emissions (in thousand metric tons of CO2 equivalent) in 2005 in Singapore?
Make the answer very short. -41.4. What is the difference between the SF6 emissions (in thousand metric tons of CO2 equivalent) in 2000 and SF6 emissions (in thousand metric tons of CO2 equivalent) in 2008 in Singapore?
Give a very brief answer. -125.7. What is the difference between the SF6 emissions (in thousand metric tons of CO2 equivalent) of 2005 and SF6 emissions (in thousand metric tons of CO2 equivalent) of 2008 in Singapore?
Offer a terse response. -84.3. What is the ratio of the SF6 emissions (in thousand metric tons of CO2 equivalent) of 1990 in Poland to that in Portugal?
Your response must be concise. 0.97. What is the ratio of the SF6 emissions (in thousand metric tons of CO2 equivalent) in 2000 in Poland to that in Portugal?
Your answer should be compact. 1.48. What is the ratio of the SF6 emissions (in thousand metric tons of CO2 equivalent) of 2005 in Poland to that in Portugal?
Make the answer very short. 2.1. What is the ratio of the SF6 emissions (in thousand metric tons of CO2 equivalent) of 2008 in Poland to that in Portugal?
Provide a succinct answer. 1.9. What is the ratio of the SF6 emissions (in thousand metric tons of CO2 equivalent) of 1990 in Poland to that in Romania?
Provide a short and direct response. 65.19. What is the ratio of the SF6 emissions (in thousand metric tons of CO2 equivalent) in 2000 in Poland to that in Romania?
Offer a terse response. 94.9. What is the ratio of the SF6 emissions (in thousand metric tons of CO2 equivalent) in 2005 in Poland to that in Romania?
Offer a terse response. 99.32. What is the ratio of the SF6 emissions (in thousand metric tons of CO2 equivalent) of 2008 in Poland to that in Romania?
Provide a short and direct response. 109.43. What is the ratio of the SF6 emissions (in thousand metric tons of CO2 equivalent) of 1990 in Poland to that in Russian Federation?
Provide a succinct answer. 0.02. What is the ratio of the SF6 emissions (in thousand metric tons of CO2 equivalent) in 2000 in Poland to that in Russian Federation?
Provide a short and direct response. 0.02. What is the ratio of the SF6 emissions (in thousand metric tons of CO2 equivalent) in 2005 in Poland to that in Russian Federation?
Give a very brief answer. 0.02. What is the ratio of the SF6 emissions (in thousand metric tons of CO2 equivalent) in 2008 in Poland to that in Russian Federation?
Keep it short and to the point. 0.03. What is the ratio of the SF6 emissions (in thousand metric tons of CO2 equivalent) in 1990 in Poland to that in Saudi Arabia?
Your answer should be very brief. 0.04. What is the ratio of the SF6 emissions (in thousand metric tons of CO2 equivalent) in 2000 in Poland to that in Saudi Arabia?
Provide a short and direct response. 0.15. What is the ratio of the SF6 emissions (in thousand metric tons of CO2 equivalent) of 2005 in Poland to that in Saudi Arabia?
Offer a very short reply. 0.11. What is the ratio of the SF6 emissions (in thousand metric tons of CO2 equivalent) of 2008 in Poland to that in Saudi Arabia?
Your answer should be very brief. 0.11. What is the ratio of the SF6 emissions (in thousand metric tons of CO2 equivalent) in 1990 in Poland to that in Singapore?
Give a very brief answer. 0.29. What is the ratio of the SF6 emissions (in thousand metric tons of CO2 equivalent) in 2000 in Poland to that in Singapore?
Your answer should be very brief. 0.73. What is the ratio of the SF6 emissions (in thousand metric tons of CO2 equivalent) in 2005 in Poland to that in Singapore?
Make the answer very short. 0.73. What is the ratio of the SF6 emissions (in thousand metric tons of CO2 equivalent) in 2008 in Poland to that in Singapore?
Provide a short and direct response. 0.65. What is the ratio of the SF6 emissions (in thousand metric tons of CO2 equivalent) of 1990 in Portugal to that in Romania?
Ensure brevity in your answer.  67.5. What is the ratio of the SF6 emissions (in thousand metric tons of CO2 equivalent) in 2005 in Portugal to that in Romania?
Your response must be concise. 47.18. What is the ratio of the SF6 emissions (in thousand metric tons of CO2 equivalent) of 2008 in Portugal to that in Romania?
Your answer should be compact. 57.57. What is the ratio of the SF6 emissions (in thousand metric tons of CO2 equivalent) in 1990 in Portugal to that in Russian Federation?
Your answer should be compact. 0.02. What is the ratio of the SF6 emissions (in thousand metric tons of CO2 equivalent) in 2000 in Portugal to that in Russian Federation?
Ensure brevity in your answer.  0.01. What is the ratio of the SF6 emissions (in thousand metric tons of CO2 equivalent) of 2005 in Portugal to that in Russian Federation?
Keep it short and to the point. 0.01. What is the ratio of the SF6 emissions (in thousand metric tons of CO2 equivalent) of 2008 in Portugal to that in Russian Federation?
Provide a short and direct response. 0.01. What is the ratio of the SF6 emissions (in thousand metric tons of CO2 equivalent) of 1990 in Portugal to that in Saudi Arabia?
Your answer should be very brief. 0.04. What is the ratio of the SF6 emissions (in thousand metric tons of CO2 equivalent) in 2000 in Portugal to that in Saudi Arabia?
Offer a terse response. 0.1. What is the ratio of the SF6 emissions (in thousand metric tons of CO2 equivalent) in 2005 in Portugal to that in Saudi Arabia?
Provide a short and direct response. 0.05. What is the ratio of the SF6 emissions (in thousand metric tons of CO2 equivalent) in 2008 in Portugal to that in Saudi Arabia?
Your answer should be compact. 0.06. What is the ratio of the SF6 emissions (in thousand metric tons of CO2 equivalent) in 1990 in Portugal to that in Singapore?
Provide a short and direct response. 0.3. What is the ratio of the SF6 emissions (in thousand metric tons of CO2 equivalent) in 2000 in Portugal to that in Singapore?
Keep it short and to the point. 0.49. What is the ratio of the SF6 emissions (in thousand metric tons of CO2 equivalent) in 2005 in Portugal to that in Singapore?
Your answer should be very brief. 0.34. What is the ratio of the SF6 emissions (in thousand metric tons of CO2 equivalent) in 2008 in Portugal to that in Singapore?
Ensure brevity in your answer.  0.34. What is the ratio of the SF6 emissions (in thousand metric tons of CO2 equivalent) in 1990 in Romania to that in Russian Federation?
Make the answer very short. 0. What is the ratio of the SF6 emissions (in thousand metric tons of CO2 equivalent) in 2000 in Romania to that in Russian Federation?
Offer a terse response. 0. What is the ratio of the SF6 emissions (in thousand metric tons of CO2 equivalent) in 2008 in Romania to that in Russian Federation?
Offer a terse response. 0. What is the ratio of the SF6 emissions (in thousand metric tons of CO2 equivalent) of 1990 in Romania to that in Saudi Arabia?
Offer a very short reply. 0. What is the ratio of the SF6 emissions (in thousand metric tons of CO2 equivalent) in 2000 in Romania to that in Saudi Arabia?
Your response must be concise. 0. What is the ratio of the SF6 emissions (in thousand metric tons of CO2 equivalent) of 2005 in Romania to that in Saudi Arabia?
Offer a terse response. 0. What is the ratio of the SF6 emissions (in thousand metric tons of CO2 equivalent) of 2008 in Romania to that in Saudi Arabia?
Your answer should be very brief. 0. What is the ratio of the SF6 emissions (in thousand metric tons of CO2 equivalent) in 1990 in Romania to that in Singapore?
Offer a terse response. 0. What is the ratio of the SF6 emissions (in thousand metric tons of CO2 equivalent) of 2000 in Romania to that in Singapore?
Your answer should be very brief. 0.01. What is the ratio of the SF6 emissions (in thousand metric tons of CO2 equivalent) in 2005 in Romania to that in Singapore?
Offer a very short reply. 0.01. What is the ratio of the SF6 emissions (in thousand metric tons of CO2 equivalent) in 2008 in Romania to that in Singapore?
Offer a terse response. 0.01. What is the ratio of the SF6 emissions (in thousand metric tons of CO2 equivalent) of 1990 in Russian Federation to that in Saudi Arabia?
Offer a terse response. 2. What is the ratio of the SF6 emissions (in thousand metric tons of CO2 equivalent) in 2000 in Russian Federation to that in Saudi Arabia?
Keep it short and to the point. 7.14. What is the ratio of the SF6 emissions (in thousand metric tons of CO2 equivalent) in 2005 in Russian Federation to that in Saudi Arabia?
Give a very brief answer. 4.71. What is the ratio of the SF6 emissions (in thousand metric tons of CO2 equivalent) of 2008 in Russian Federation to that in Saudi Arabia?
Offer a terse response. 4.07. What is the ratio of the SF6 emissions (in thousand metric tons of CO2 equivalent) of 1990 in Russian Federation to that in Singapore?
Keep it short and to the point. 13.4. What is the ratio of the SF6 emissions (in thousand metric tons of CO2 equivalent) in 2000 in Russian Federation to that in Singapore?
Provide a short and direct response. 34.77. What is the ratio of the SF6 emissions (in thousand metric tons of CO2 equivalent) in 2005 in Russian Federation to that in Singapore?
Ensure brevity in your answer.  30.84. What is the ratio of the SF6 emissions (in thousand metric tons of CO2 equivalent) of 2008 in Russian Federation to that in Singapore?
Keep it short and to the point. 24.51. What is the ratio of the SF6 emissions (in thousand metric tons of CO2 equivalent) in 1990 in Saudi Arabia to that in Singapore?
Offer a very short reply. 6.69. What is the ratio of the SF6 emissions (in thousand metric tons of CO2 equivalent) in 2000 in Saudi Arabia to that in Singapore?
Provide a succinct answer. 4.87. What is the ratio of the SF6 emissions (in thousand metric tons of CO2 equivalent) of 2005 in Saudi Arabia to that in Singapore?
Keep it short and to the point. 6.55. What is the ratio of the SF6 emissions (in thousand metric tons of CO2 equivalent) of 2008 in Saudi Arabia to that in Singapore?
Your answer should be compact. 6.02. What is the difference between the highest and the second highest SF6 emissions (in thousand metric tons of CO2 equivalent) in 1990?
Give a very brief answer. 2445.5. What is the difference between the highest and the second highest SF6 emissions (in thousand metric tons of CO2 equivalent) in 2000?
Offer a terse response. 7768.6. What is the difference between the highest and the second highest SF6 emissions (in thousand metric tons of CO2 equivalent) in 2005?
Provide a succinct answer. 7316.1. What is the difference between the highest and the second highest SF6 emissions (in thousand metric tons of CO2 equivalent) of 2008?
Make the answer very short. 7126.4. What is the difference between the highest and the lowest SF6 emissions (in thousand metric tons of CO2 equivalent) of 1990?
Provide a succinct answer. 4885.2. What is the difference between the highest and the lowest SF6 emissions (in thousand metric tons of CO2 equivalent) in 2000?
Offer a very short reply. 9031.2. What is the difference between the highest and the lowest SF6 emissions (in thousand metric tons of CO2 equivalent) in 2005?
Your answer should be very brief. 9287.7. What is the difference between the highest and the lowest SF6 emissions (in thousand metric tons of CO2 equivalent) in 2008?
Ensure brevity in your answer.  9445.9. 